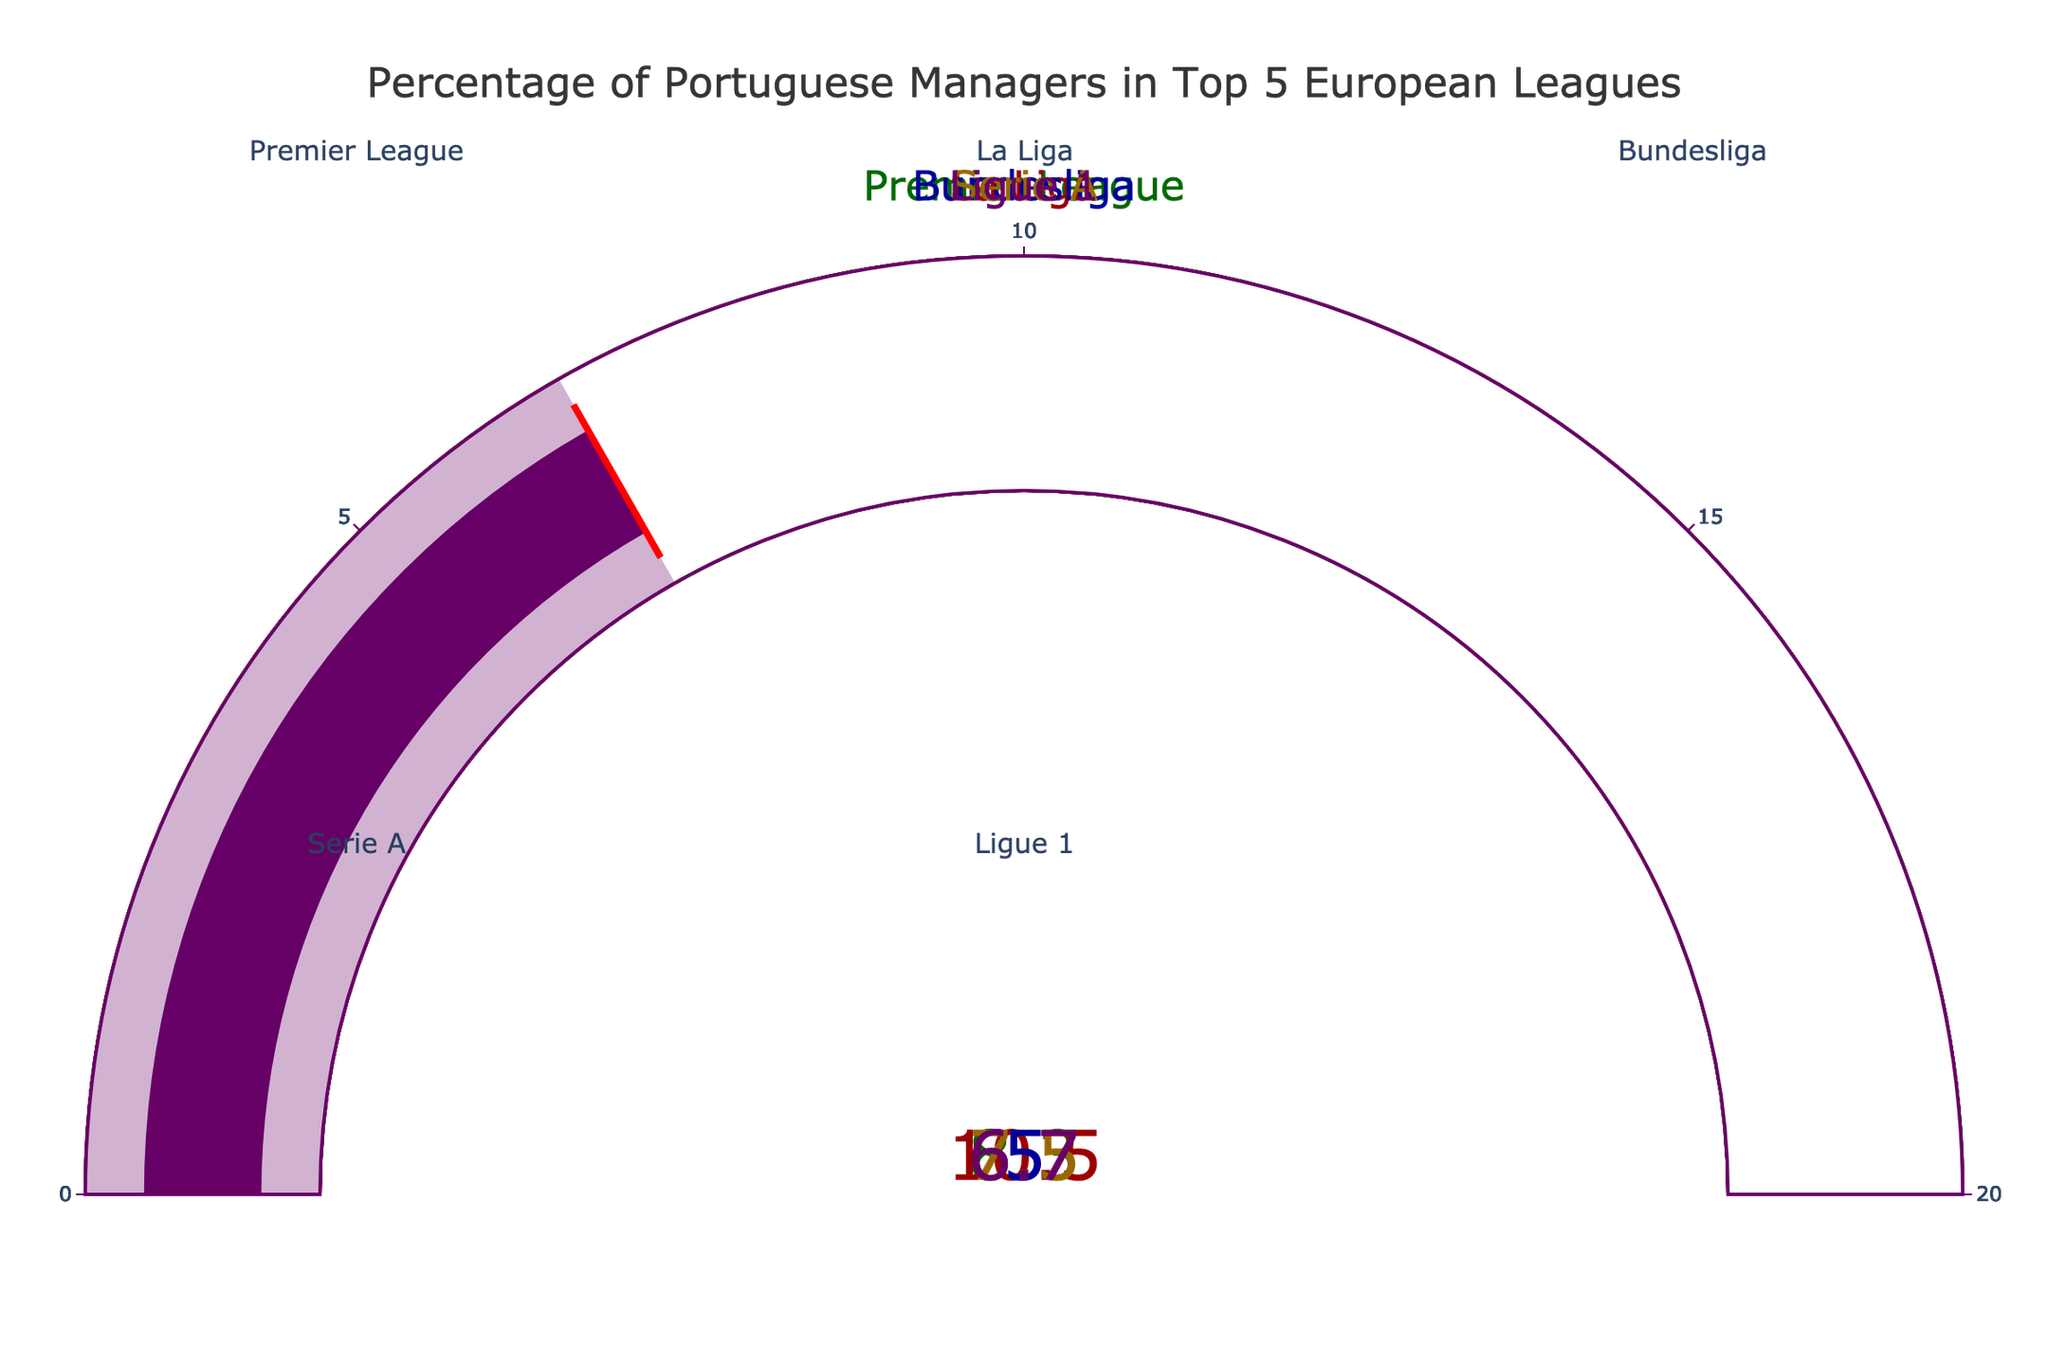What is the title of the figure? The title is usually positioned at the top of the figure, centrally aligned, which can be read as "Percentage of Portuguese Managers in Top 5 European Leagues."
Answer: Percentage of Portuguese Managers in Top 5 European Leagues Which league has the highest percentage of Portuguese managers? By comparing the values displayed on each gauge, La Liga has the highest percentage at 10.5%.
Answer: La Liga What is the percentage of Portuguese managers in the Premier League? Look at the gauge corresponding to the Premier League, which shows the value as 8.3%.
Answer: 8.3% What is the average percentage of Portuguese managers across all the leagues? Sum the percentages (8.3 + 10.5 + 5.0 + 7.5 + 6.7) to get 38, then divide by 5 leagues: 38 / 5 = 7.6%.
Answer: 7.6% Which league has the lowest percentage of Portuguese managers? By comparing the values displayed on each gauge, the Bundesliga has the lowest percentage at 5.0%.
Answer: Bundesliga How much higher is the percentage of Portuguese managers in La Liga compared to Serie A? Subtract the percentage in Serie A (7.5%) from the percentage in La Liga (10.5%): 10.5 - 7.5 = 3.0%.
Answer: 3.0% What are the exact percentages of Portuguese managers in both Ligue 1 and the Bundesliga? Identify the values shown on the separate gauges for each league-- 6.7% for Ligue 1 and 5.0% for the Bundesliga.
Answer: 6.7% and 5.0% Are there any leagues with the same percentage of Portuguese managers? Compare each percentage shown on the gauges and confirm that no two leagues display the same value.
Answer: No Is the percentage of Portuguese managers in the Premier League higher or lower than the overall average? Calculate the average percentage as previously determined (7.6%), then compare it to the Premier League's 8.3%. Since 8.3% is greater, the Premier League is higher.
Answer: Higher By how much does the percentage of Portuguese managers vary between the highest and lowest leagues? Subtract the lowest percentage (5.0% in the Bundesliga) from the highest percentage (10.5% in La Liga): 10.5 - 5.0 = 5.5%.
Answer: 5.5% 